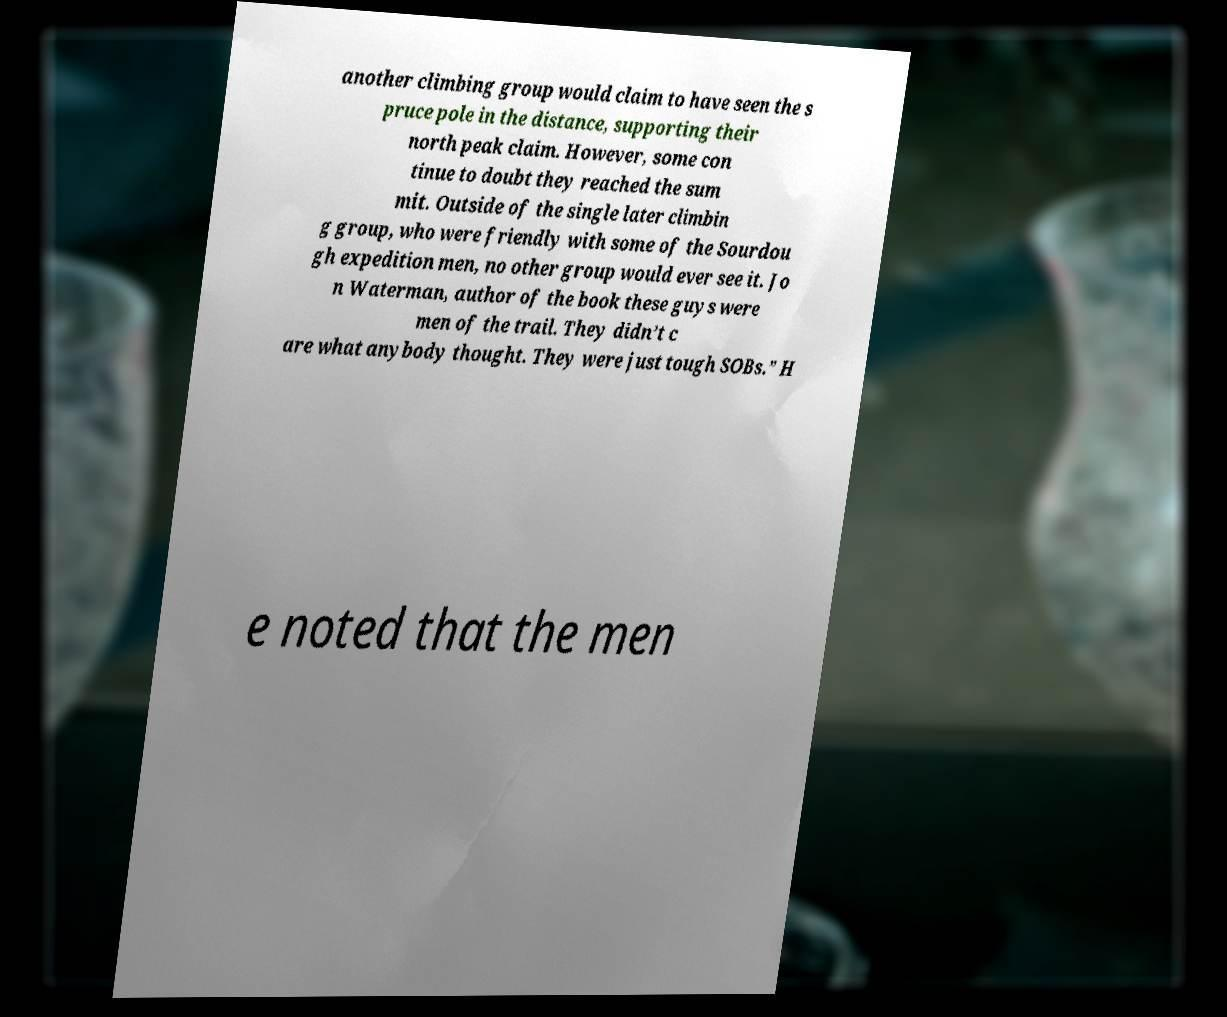I need the written content from this picture converted into text. Can you do that? another climbing group would claim to have seen the s pruce pole in the distance, supporting their north peak claim. However, some con tinue to doubt they reached the sum mit. Outside of the single later climbin g group, who were friendly with some of the Sourdou gh expedition men, no other group would ever see it. Jo n Waterman, author of the book these guys were men of the trail. They didn’t c are what anybody thought. They were just tough SOBs.” H e noted that the men 